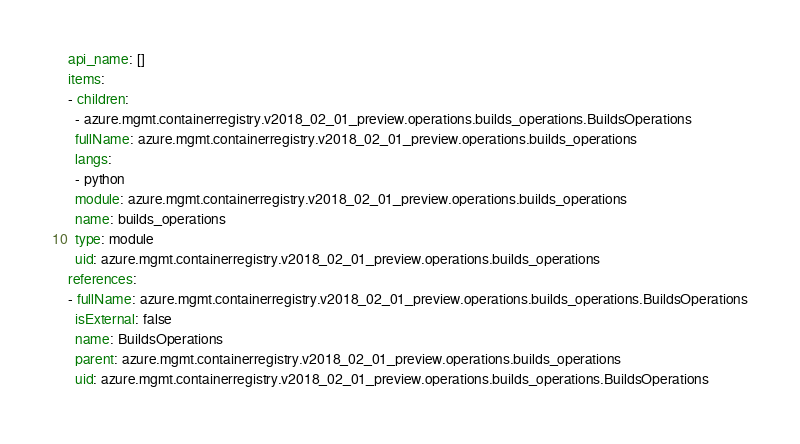Convert code to text. <code><loc_0><loc_0><loc_500><loc_500><_YAML_>api_name: []
items:
- children:
  - azure.mgmt.containerregistry.v2018_02_01_preview.operations.builds_operations.BuildsOperations
  fullName: azure.mgmt.containerregistry.v2018_02_01_preview.operations.builds_operations
  langs:
  - python
  module: azure.mgmt.containerregistry.v2018_02_01_preview.operations.builds_operations
  name: builds_operations
  type: module
  uid: azure.mgmt.containerregistry.v2018_02_01_preview.operations.builds_operations
references:
- fullName: azure.mgmt.containerregistry.v2018_02_01_preview.operations.builds_operations.BuildsOperations
  isExternal: false
  name: BuildsOperations
  parent: azure.mgmt.containerregistry.v2018_02_01_preview.operations.builds_operations
  uid: azure.mgmt.containerregistry.v2018_02_01_preview.operations.builds_operations.BuildsOperations
</code> 